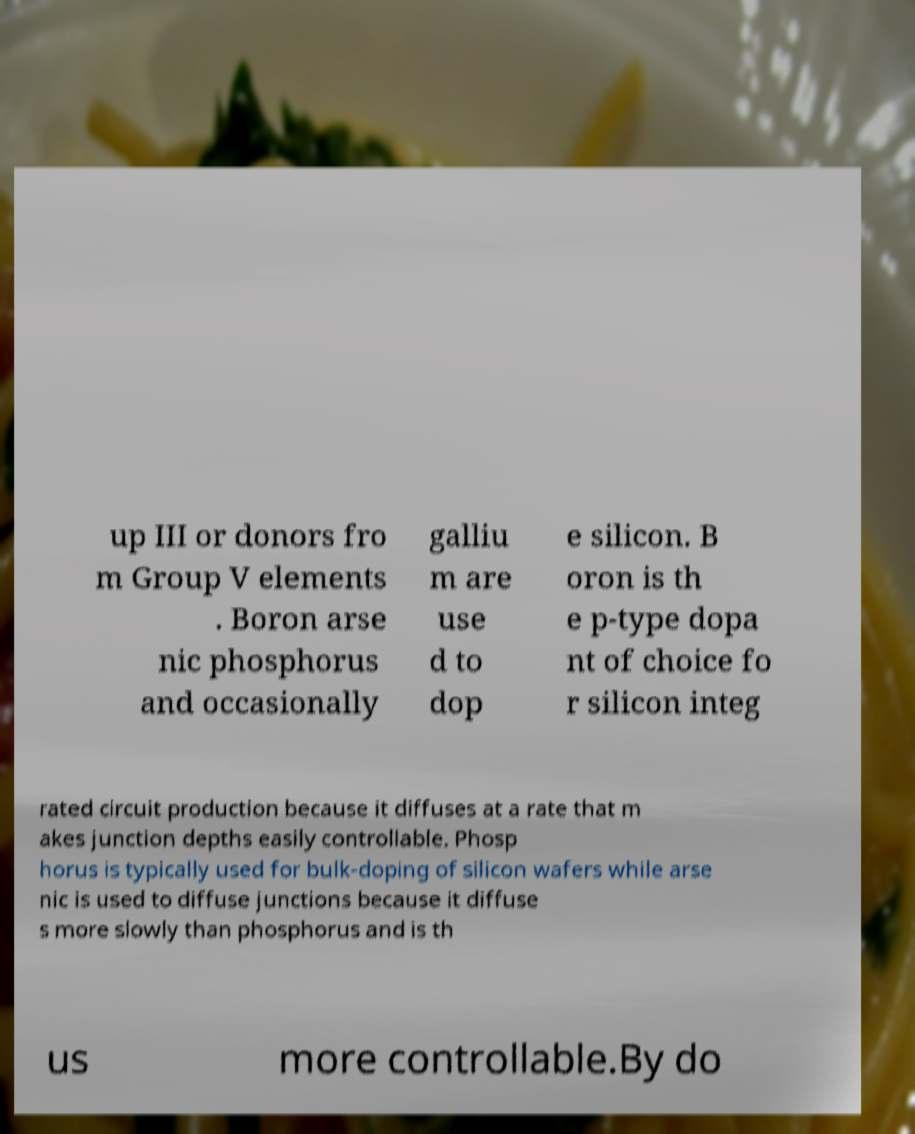Please identify and transcribe the text found in this image. up III or donors fro m Group V elements . Boron arse nic phosphorus and occasionally galliu m are use d to dop e silicon. B oron is th e p-type dopa nt of choice fo r silicon integ rated circuit production because it diffuses at a rate that m akes junction depths easily controllable. Phosp horus is typically used for bulk-doping of silicon wafers while arse nic is used to diffuse junctions because it diffuse s more slowly than phosphorus and is th us more controllable.By do 